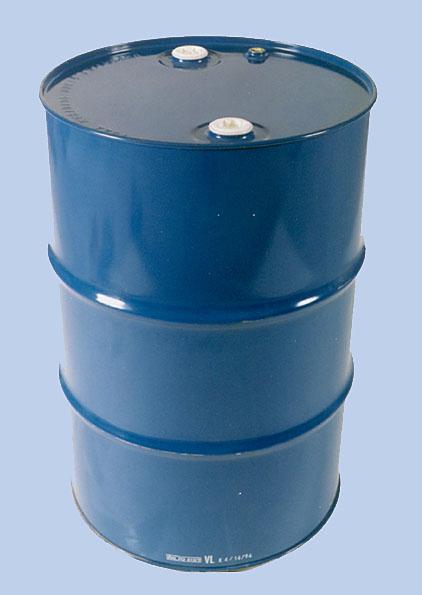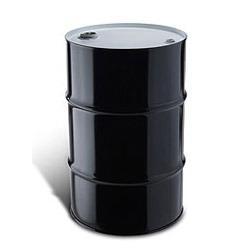The first image is the image on the left, the second image is the image on the right. Examine the images to the left and right. Is the description "In at least one image there is a black metal barrel with a lid on." accurate? Answer yes or no. Yes. 